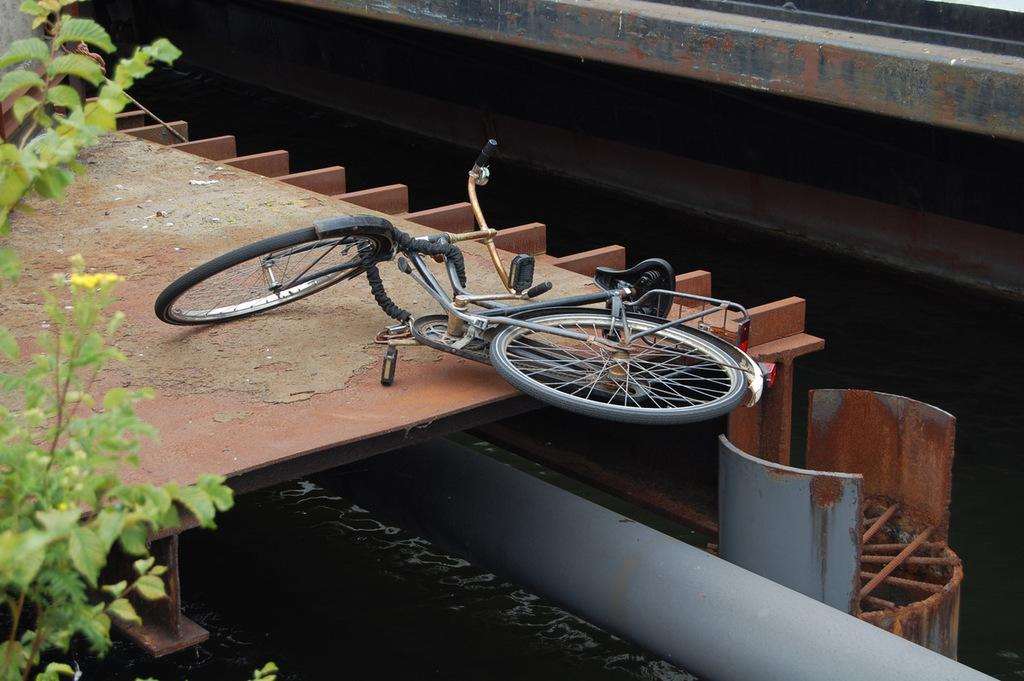What is the main object in the image? There is a bicycle in the image. Can you describe the surface the bicycle is on? The bicycle is on some surface, but the specific type of surface is not mentioned in the facts. What other elements are present in the image besides the bicycle? There are plants in the image. What color are the plants? The plants are green in color. What type of letters can be seen on the bicycle in the image? There are no letters visible on the bicycle in the image. Can you tell me how many goldfish are swimming in the plants in the image? There are no goldfish present in the image; it features a bicycle and plants. 